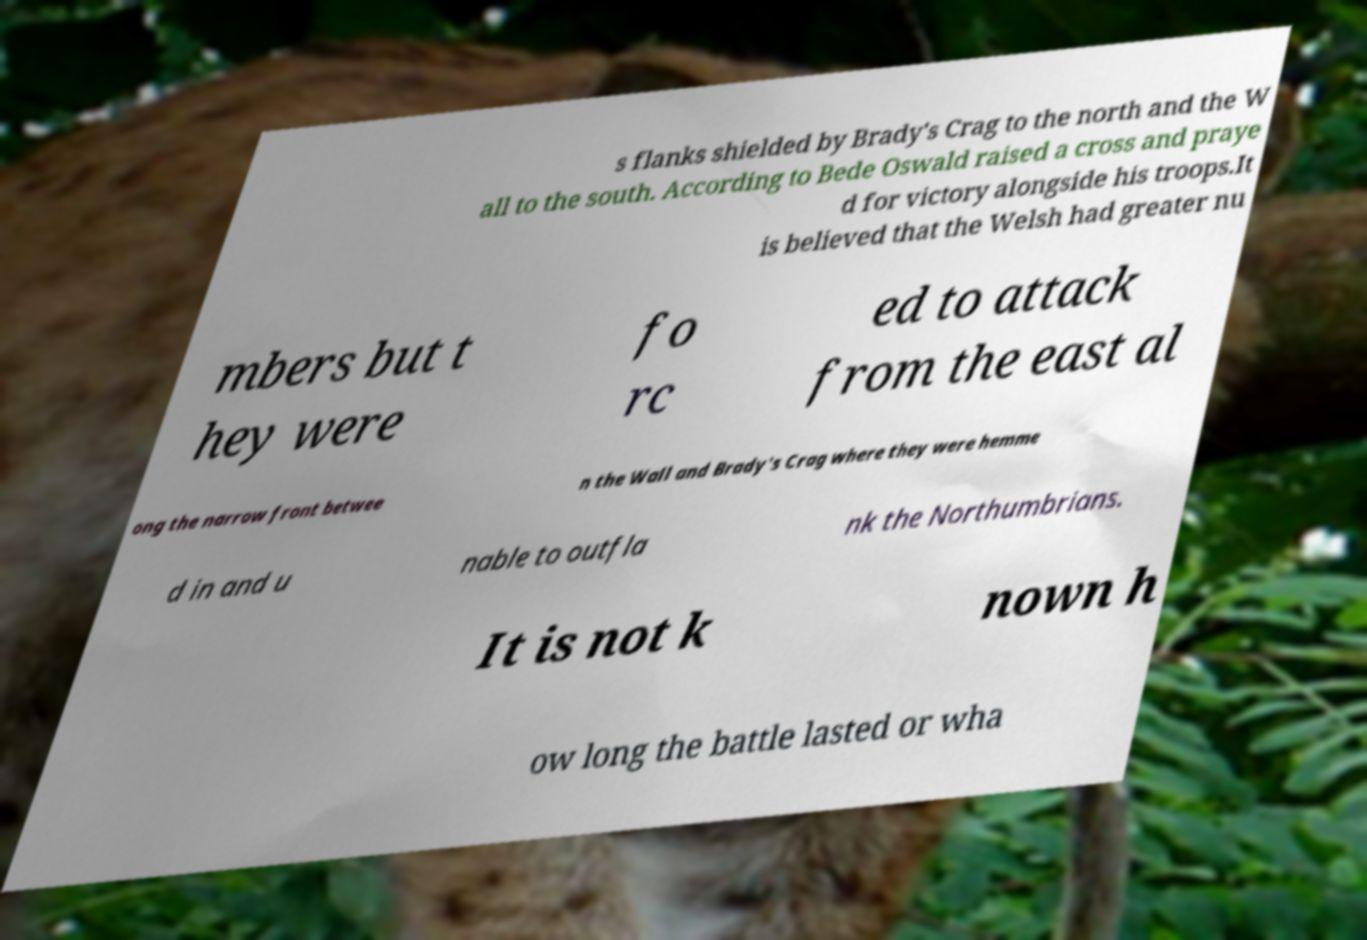Could you assist in decoding the text presented in this image and type it out clearly? s flanks shielded by Brady's Crag to the north and the W all to the south. According to Bede Oswald raised a cross and praye d for victory alongside his troops.It is believed that the Welsh had greater nu mbers but t hey were fo rc ed to attack from the east al ong the narrow front betwee n the Wall and Brady's Crag where they were hemme d in and u nable to outfla nk the Northumbrians. It is not k nown h ow long the battle lasted or wha 